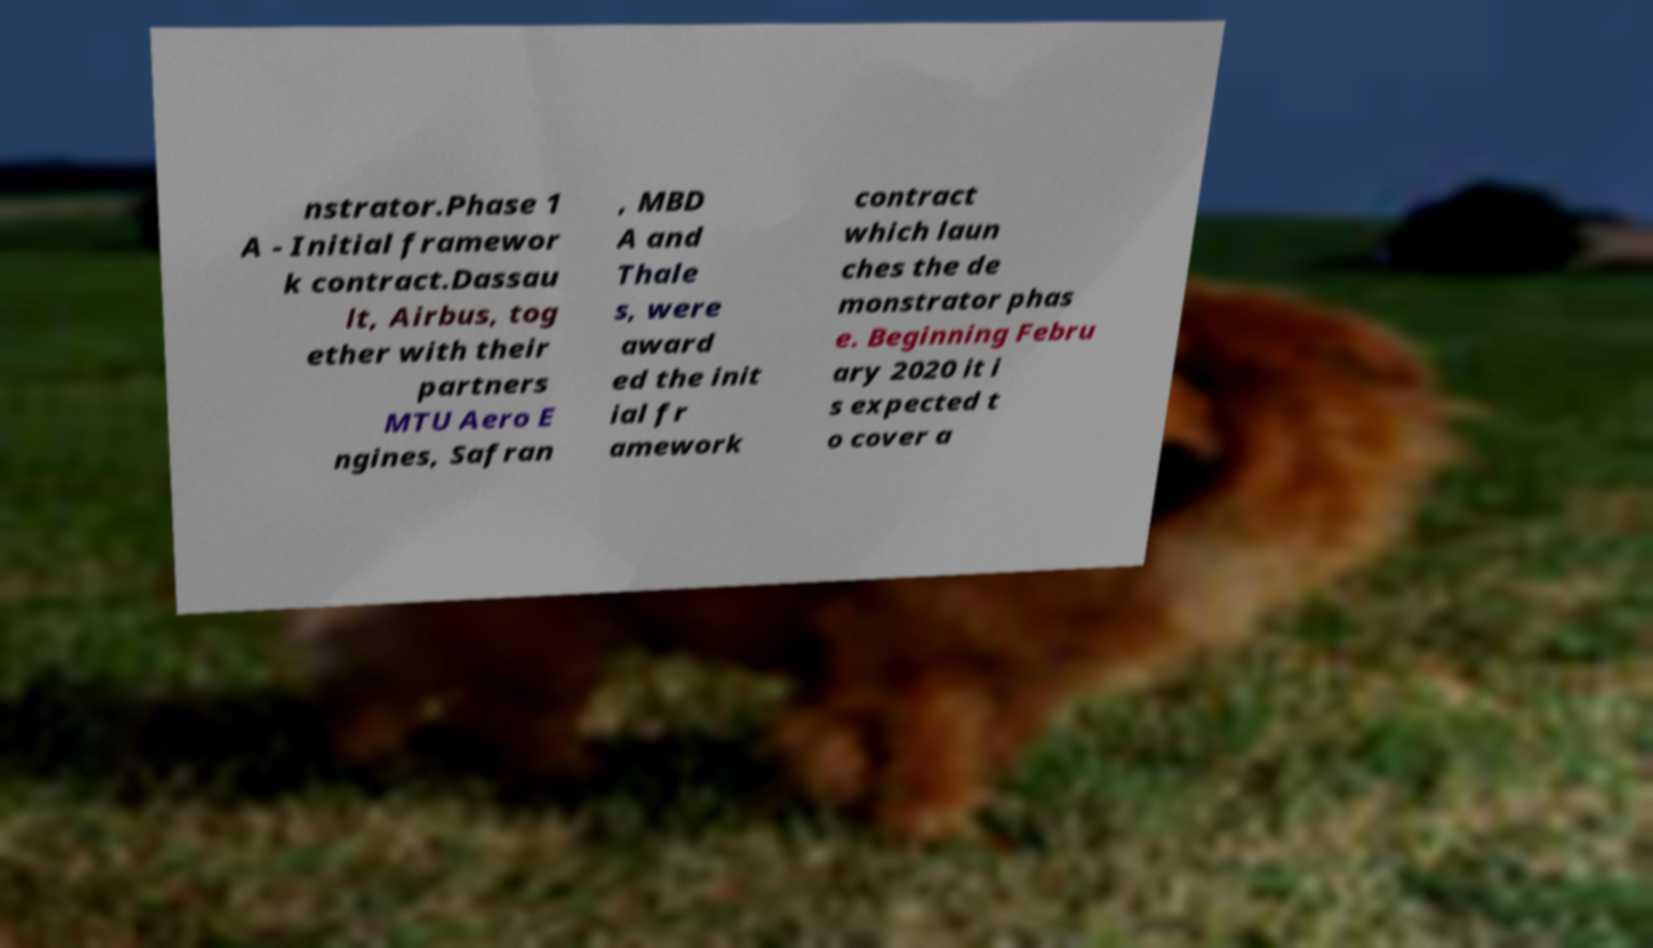Please identify and transcribe the text found in this image. nstrator.Phase 1 A - Initial framewor k contract.Dassau lt, Airbus, tog ether with their partners MTU Aero E ngines, Safran , MBD A and Thale s, were award ed the init ial fr amework contract which laun ches the de monstrator phas e. Beginning Febru ary 2020 it i s expected t o cover a 